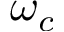Convert formula to latex. <formula><loc_0><loc_0><loc_500><loc_500>\omega _ { c }</formula> 